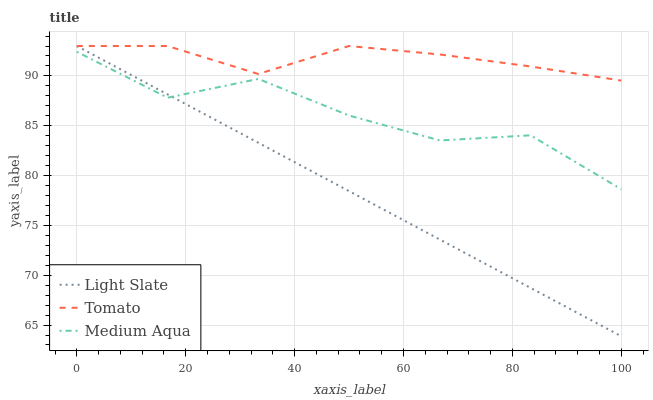Does Light Slate have the minimum area under the curve?
Answer yes or no. Yes. Does Tomato have the maximum area under the curve?
Answer yes or no. Yes. Does Medium Aqua have the minimum area under the curve?
Answer yes or no. No. Does Medium Aqua have the maximum area under the curve?
Answer yes or no. No. Is Light Slate the smoothest?
Answer yes or no. Yes. Is Medium Aqua the roughest?
Answer yes or no. Yes. Is Tomato the smoothest?
Answer yes or no. No. Is Tomato the roughest?
Answer yes or no. No. Does Medium Aqua have the lowest value?
Answer yes or no. No. Does Medium Aqua have the highest value?
Answer yes or no. No. Is Medium Aqua less than Tomato?
Answer yes or no. Yes. Is Tomato greater than Medium Aqua?
Answer yes or no. Yes. Does Medium Aqua intersect Tomato?
Answer yes or no. No. 